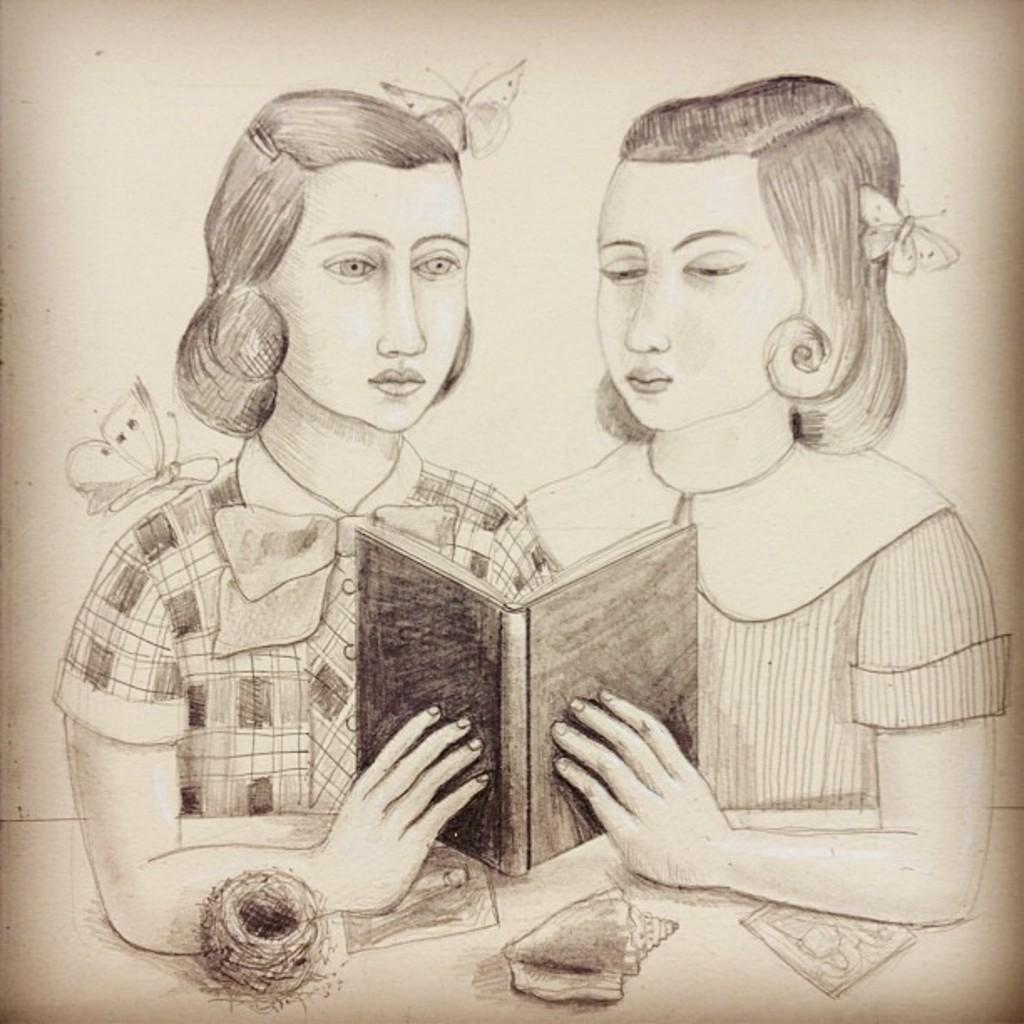What is depicted in the image involving two persons? There is a drawing of two persons in the image. What are the two persons doing in the drawing? The two persons are sitting. What are the two persons holding in the drawing? The two persons are holding a book. What can be seen in the image besides the drawing of the two persons? There is a table in the image, and there are objects on the table. What else is present in the image? There are butterflies in the image. What type of education is being provided to the butterflies in the image? There is no indication in the image that the butterflies are receiving any education. 